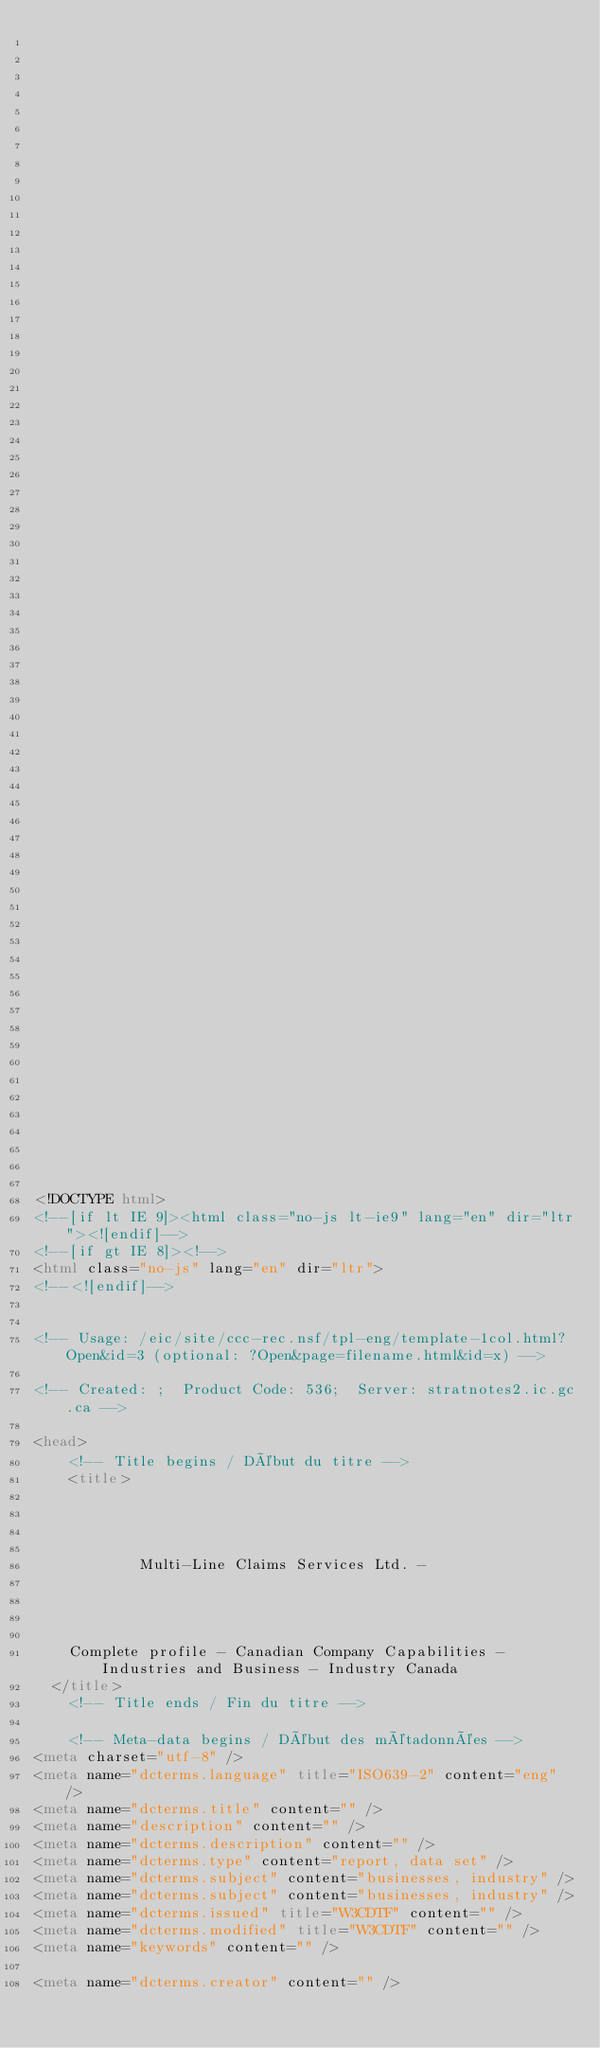<code> <loc_0><loc_0><loc_500><loc_500><_HTML_>


















	






  
  
  
  































	
	
	



<!DOCTYPE html>
<!--[if lt IE 9]><html class="no-js lt-ie9" lang="en" dir="ltr"><![endif]-->
<!--[if gt IE 8]><!-->
<html class="no-js" lang="en" dir="ltr">
<!--<![endif]-->


<!-- Usage: /eic/site/ccc-rec.nsf/tpl-eng/template-1col.html?Open&id=3 (optional: ?Open&page=filename.html&id=x) -->

<!-- Created: ;  Product Code: 536;  Server: stratnotes2.ic.gc.ca -->

<head>
	<!-- Title begins / Début du titre -->
	<title>
    
            
        
          
            Multi-Line Claims Services Ltd. -
          
        
      
    
    Complete profile - Canadian Company Capabilities - Industries and Business - Industry Canada
  </title>
	<!-- Title ends / Fin du titre -->
 
	<!-- Meta-data begins / Début des métadonnées -->
<meta charset="utf-8" />
<meta name="dcterms.language" title="ISO639-2" content="eng" />
<meta name="dcterms.title" content="" />
<meta name="description" content="" />
<meta name="dcterms.description" content="" />
<meta name="dcterms.type" content="report, data set" />
<meta name="dcterms.subject" content="businesses, industry" />
<meta name="dcterms.subject" content="businesses, industry" />
<meta name="dcterms.issued" title="W3CDTF" content="" />
<meta name="dcterms.modified" title="W3CDTF" content="" />
<meta name="keywords" content="" />

<meta name="dcterms.creator" content="" /></code> 